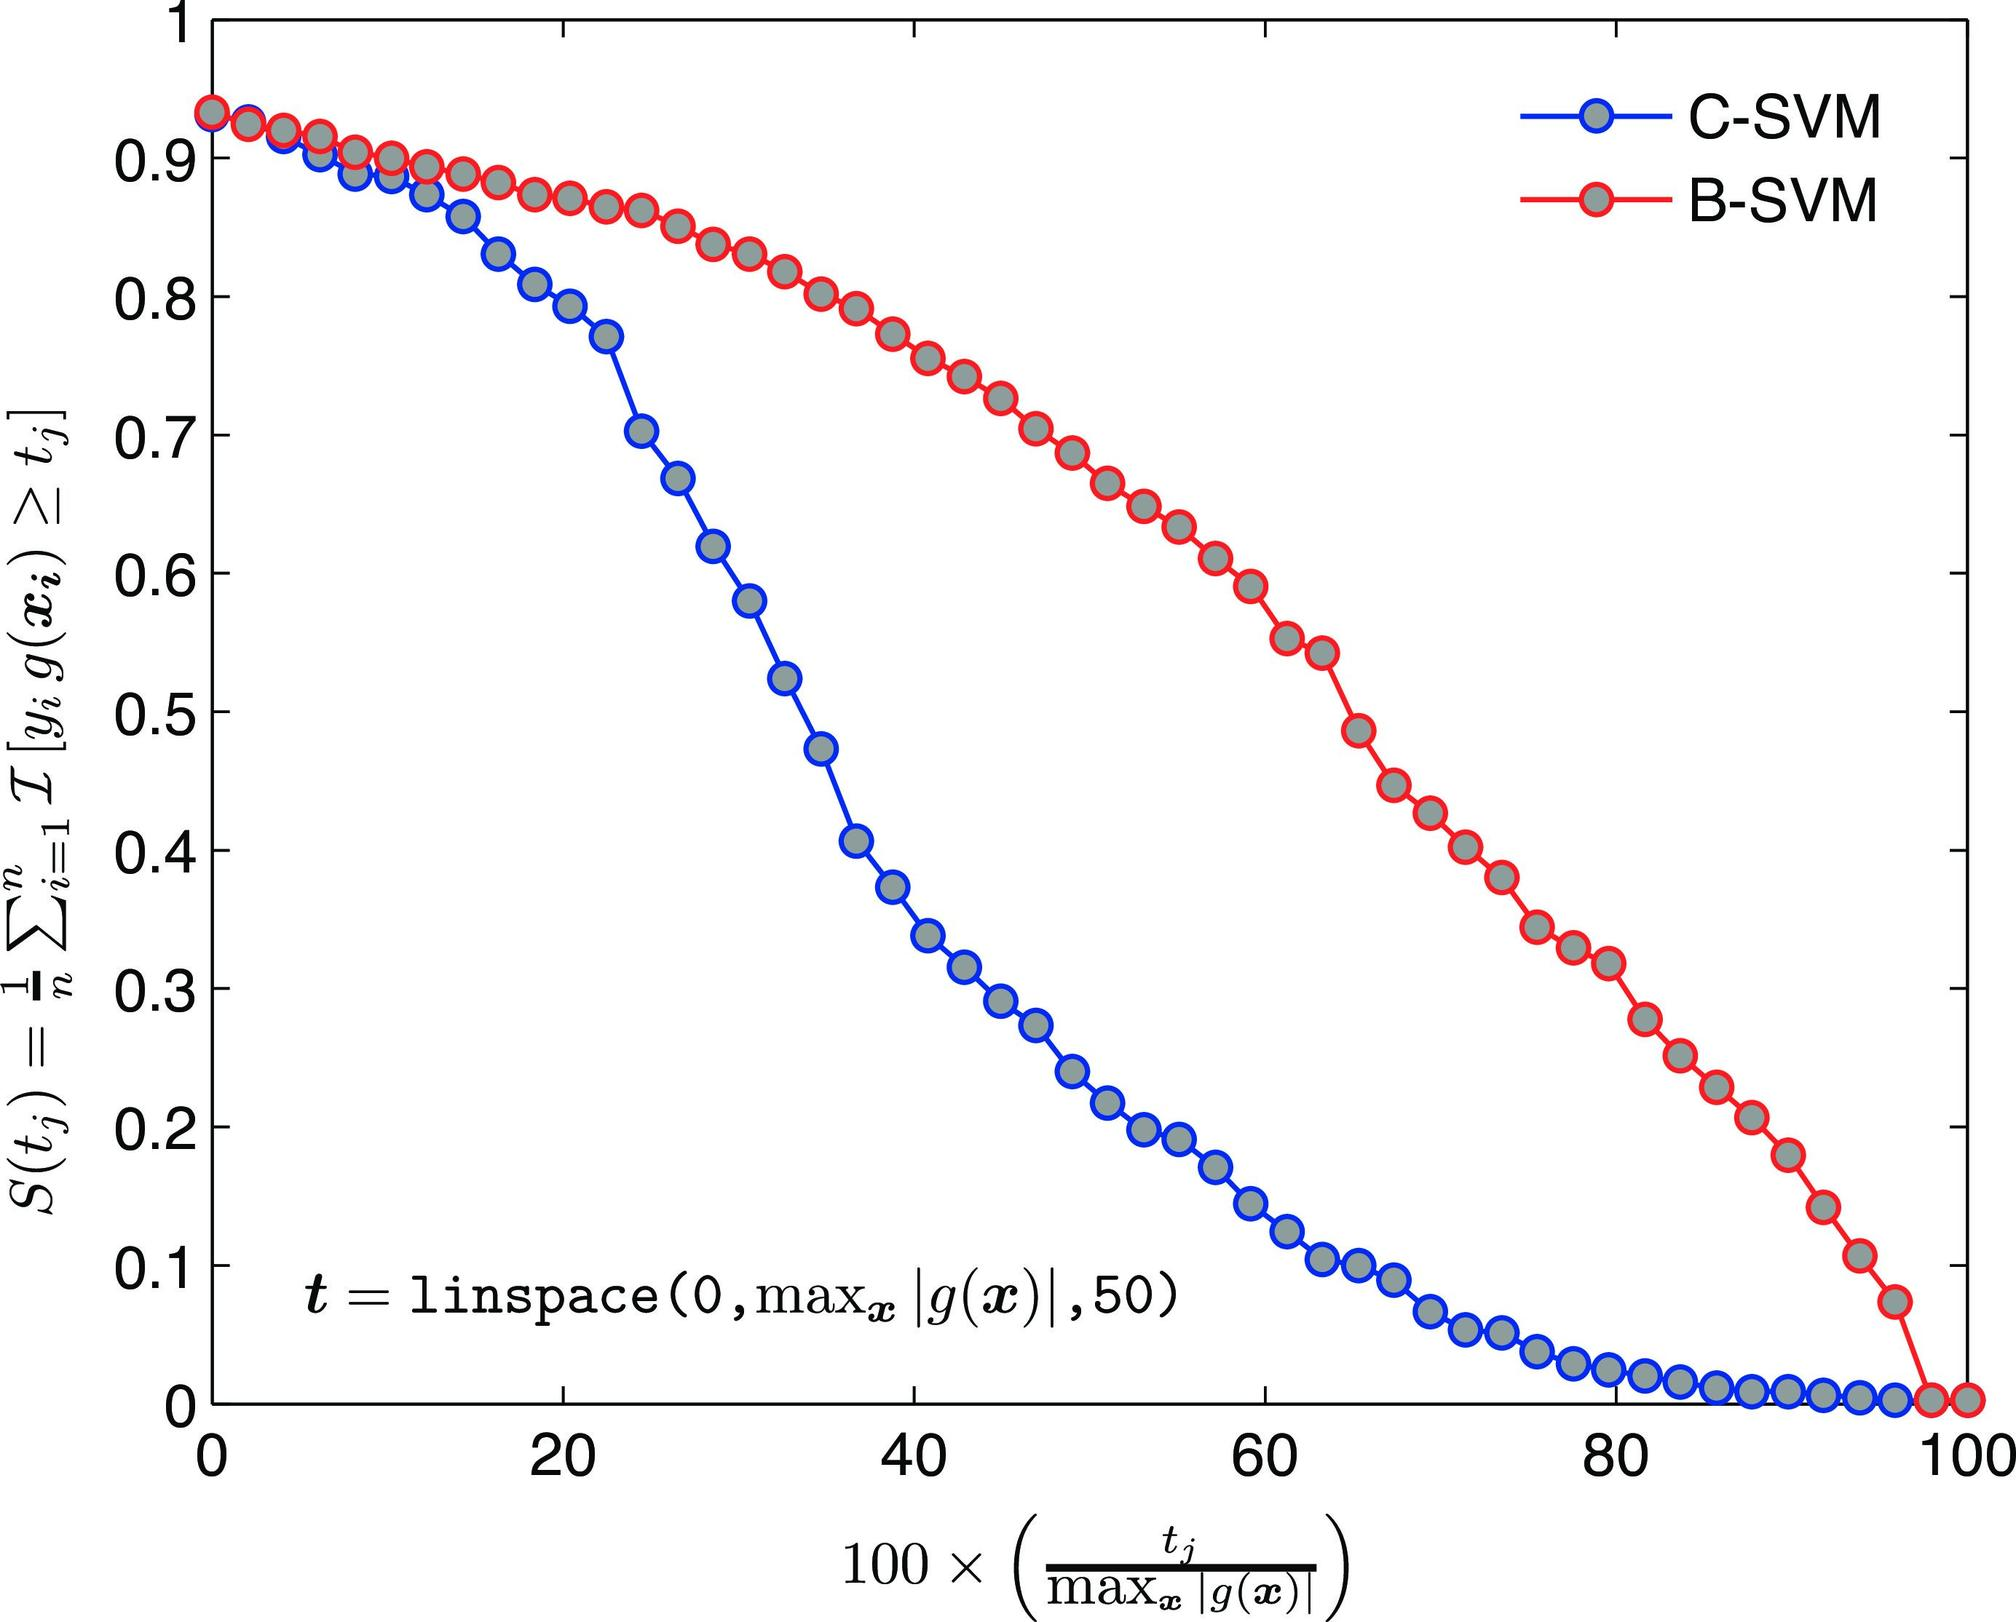What might be the potential reasons for B-SVM's performance increase over C-SVM after the point of intersection? Although we cannot assign definitive reasons without deeper context, generally speaking, the improvement in B-SVM's performance over C-SVM after the intersection could be due to B-SVM's model parameters being better suited for the dataset's characteristics beyond that specific threshold. Different SVM approaches have varied efficiencies depending on the data distribution, dimensionality, and separation margin between classes. The graph suggests B-SVM is better at generalizing or has a more favorable regularization technique for the conditions present as the value of \( t \) increases. 